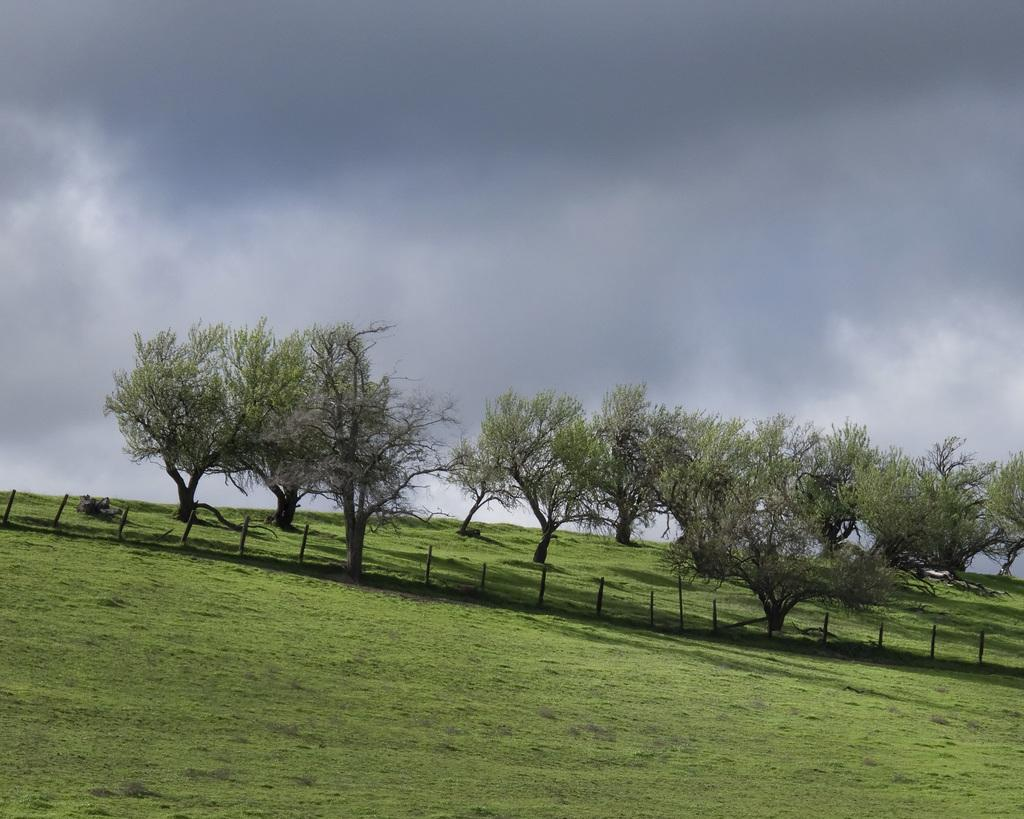What type of vegetation is in the middle of the image? There are trees in the middle of the image. What type of ground cover is at the bottom of the image? There is grass at the bottom of the image. What is visible at the top of the image? The sky is visible at the top of the image. How would you describe the sky in the image? The sky appears to be cloudy. How many boys are holding soup in the image? There are no boys or soup present in the image. What type of arm is visible in the image? There are no arms visible in the image. 